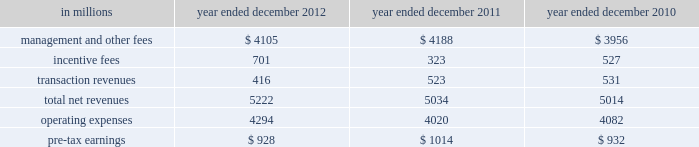Management 2019s discussion and analysis 2011 versus 2010 .
Net revenues in investing & lending were $ 2.14 billion and $ 7.54 billion for 2011 and 2010 , respectively .
During 2011 , investing & lending results reflected an operating environment characterized by a significant decline in equity markets in europe and asia , and unfavorable credit markets that were negatively impacted by increased concerns regarding the weakened state of global economies , including heightened european sovereign debt risk .
Results for 2011 included a loss of $ 517 million from our investment in the ordinary shares of icbc and net gains of $ 1.12 billion from other investments in equities , primarily in private equities , partially offset by losses from public equities .
In addition , investing & lending included net revenues of $ 96 million from debt securities and loans .
This amount includes approximately $ 1 billion of unrealized losses related to relationship lending activities , including the effect of hedges , offset by net interest income and net gains from other debt securities and loans .
Results for 2011 also included other net revenues of $ 1.44 billion , principally related to our consolidated investment entities .
Results for 2010 included a gain of $ 747 million from our investment in the ordinary shares of icbc , a net gain of $ 2.69 billion from other investments in equities , a net gain of $ 2.60 billion from debt securities and loans and other net revenues of $ 1.51 billion , principally related to our consolidated investment entities .
The net gain from other investments in equities was primarily driven by an increase in global equity markets , which resulted in appreciation of both our public and private equity positions and provided favorable conditions for initial public offerings .
The net gains and net interest from debt securities and loans primarily reflected the impact of tighter credit spreads and favorable credit markets during the year , which provided favorable conditions for borrowers to refinance .
Operating expenses were $ 2.67 billion for 2011 , 20% ( 20 % ) lower than 2010 , due to decreased compensation and benefits expenses , primarily resulting from lower net revenues .
This decrease was partially offset by the impact of impairment charges related to consolidated investments during 2011 .
Pre-tax loss was $ 531 million in 2011 , compared with pre-tax earnings of $ 4.18 billion in 2010 .
Investment management investment management provides investment management services and offers investment products ( primarily through separately managed accounts and commingled vehicles , such as mutual funds and private investment funds ) across all major asset classes to a diverse set of institutional and individual clients .
Investment management also offers wealth advisory services , including portfolio management and financial counseling , and brokerage and other transaction services to high-net-worth individuals and families .
Assets under supervision include assets under management and other client assets .
Assets under management include client assets where we earn a fee for managing assets on a discretionary basis .
This includes net assets in our mutual funds , hedge funds , credit funds and private equity funds ( including real estate funds ) , and separately managed accounts for institutional and individual investors .
Other client assets include client assets invested with third-party managers , private bank deposits and assets related to advisory relationships where we earn a fee for advisory and other services , but do not have discretion over the assets .
Assets under supervision do not include the self-directed brokerage accounts of our clients .
Assets under management and other client assets typically generate fees as a percentage of net asset value , which vary by asset class and are affected by investment performance as well as asset inflows and redemptions .
In certain circumstances , we are also entitled to receive incentive fees based on a percentage of a fund 2019s return or when the return exceeds a specified benchmark or other performance targets .
Incentive fees are recognized only when all material contingencies are resolved .
The table below presents the operating results of our investment management segment. .
56 goldman sachs 2012 annual report .
What percentage of total net revenues in the investment management segment in 2012 where due to transaction revenues? 
Computations: (416 / 5222)
Answer: 0.07966. 